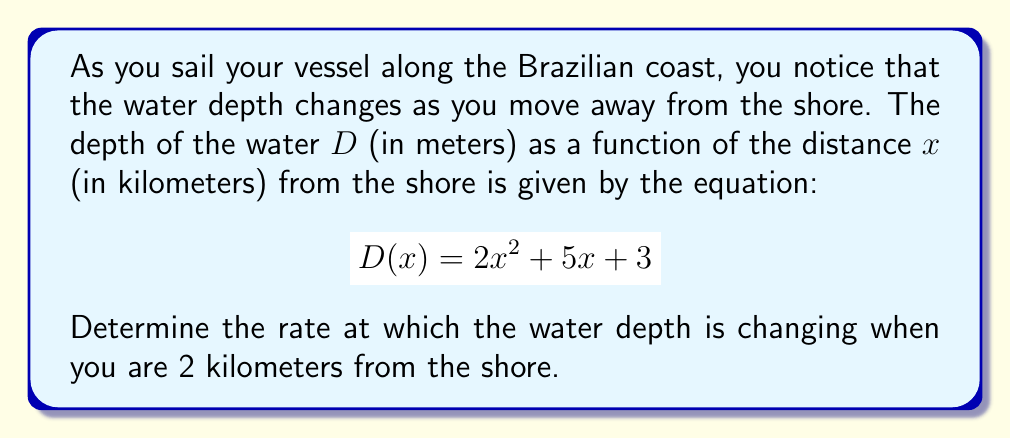Can you solve this math problem? To solve this problem, we need to find the derivative of the depth function $D(x)$ and then evaluate it at $x = 2$ km. Here's the step-by-step process:

1) The depth function is given as:
   $$D(x) = 2x^2 + 5x + 3$$

2) To find the rate of change, we need to differentiate $D(x)$ with respect to $x$:
   $$\frac{d}{dx}D(x) = \frac{d}{dx}(2x^2 + 5x + 3)$$

3) Using the power rule and the constant rule of differentiation:
   $$\frac{d}{dx}D(x) = 2 \cdot 2x^1 + 5 \cdot 1 + 0$$
   $$\frac{d}{dx}D(x) = 4x + 5$$

4) This derivative, $D'(x) = 4x + 5$, represents the rate of change of water depth with respect to distance from shore.

5) To find the rate of change at 2 km from shore, we evaluate $D'(x)$ at $x = 2$:
   $$D'(2) = 4(2) + 5 = 8 + 5 = 13$$

Therefore, when you are 2 km from the shore, the water depth is changing at a rate of 13 meters per kilometer.
Answer: 13 meters per kilometer 